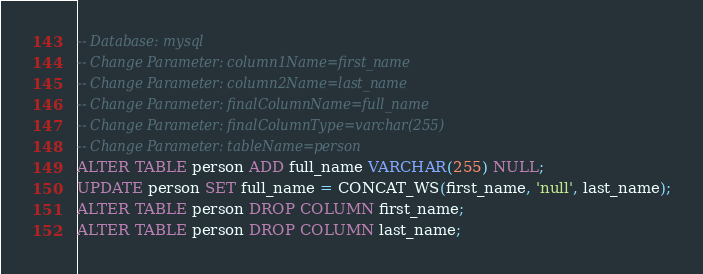Convert code to text. <code><loc_0><loc_0><loc_500><loc_500><_SQL_>-- Database: mysql
-- Change Parameter: column1Name=first_name
-- Change Parameter: column2Name=last_name
-- Change Parameter: finalColumnName=full_name
-- Change Parameter: finalColumnType=varchar(255)
-- Change Parameter: tableName=person
ALTER TABLE person ADD full_name VARCHAR(255) NULL;
UPDATE person SET full_name = CONCAT_WS(first_name, 'null', last_name);
ALTER TABLE person DROP COLUMN first_name;
ALTER TABLE person DROP COLUMN last_name;
</code> 